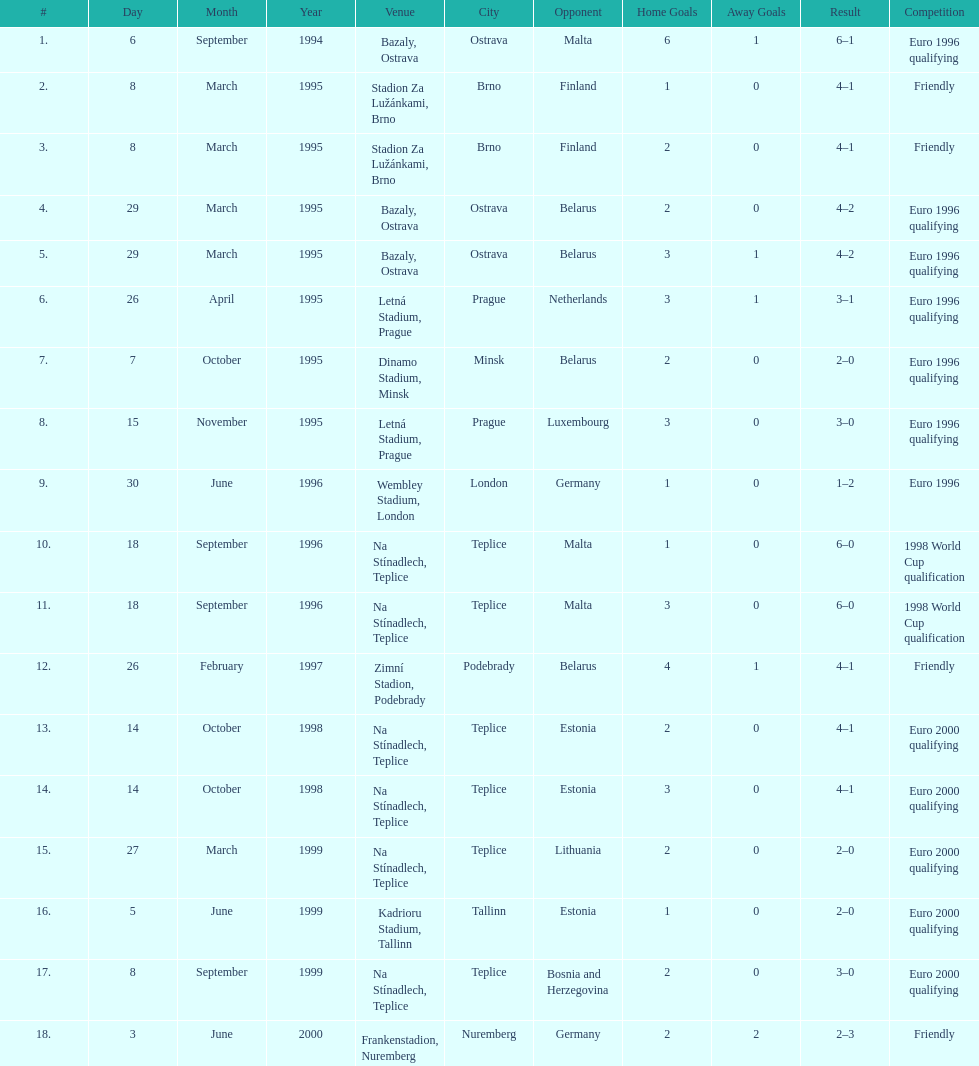Could you help me parse every detail presented in this table? {'header': ['#', 'Day', 'Month', 'Year', 'Venue', 'City', 'Opponent', 'Home Goals', 'Away Goals', 'Result', 'Competition'], 'rows': [['1.', '6', 'September', '1994', 'Bazaly, Ostrava', 'Ostrava', 'Malta', '6', '1', '6–1', 'Euro 1996 qualifying'], ['2.', '8', 'March', '1995', 'Stadion Za Lužánkami, Brno', 'Brno', 'Finland', '1', '0', '4–1', 'Friendly'], ['3.', '8', 'March', '1995', 'Stadion Za Lužánkami, Brno', 'Brno', 'Finland', '2', '0', '4–1', 'Friendly'], ['4.', '29', 'March', '1995', 'Bazaly, Ostrava', 'Ostrava', 'Belarus', '2', '0', '4–2', 'Euro 1996 qualifying'], ['5.', '29', 'March', '1995', 'Bazaly, Ostrava', 'Ostrava', 'Belarus', '3', '1', '4–2', 'Euro 1996 qualifying'], ['6.', '26', 'April', '1995', 'Letná Stadium, Prague', 'Prague', 'Netherlands', '3', '1', '3–1', 'Euro 1996 qualifying'], ['7.', '7', 'October', '1995', 'Dinamo Stadium, Minsk', 'Minsk', 'Belarus', '2', '0', '2–0', 'Euro 1996 qualifying'], ['8.', '15', 'November', '1995', 'Letná Stadium, Prague', 'Prague', 'Luxembourg', '3', '0', '3–0', 'Euro 1996 qualifying'], ['9.', '30', 'June', '1996', 'Wembley Stadium, London', 'London', 'Germany', '1', '0', '1–2', 'Euro 1996'], ['10.', '18', 'September', '1996', 'Na Stínadlech, Teplice', 'Teplice', 'Malta', '1', '0', '6–0', '1998 World Cup qualification'], ['11.', '18', 'September', '1996', 'Na Stínadlech, Teplice', 'Teplice', 'Malta', '3', '0', '6–0', '1998 World Cup qualification'], ['12.', '26', 'February', '1997', 'Zimní Stadion, Podebrady', 'Podebrady', 'Belarus', '4', '1', '4–1', 'Friendly'], ['13.', '14', 'October', '1998', 'Na Stínadlech, Teplice', 'Teplice', 'Estonia', '2', '0', '4–1', 'Euro 2000 qualifying'], ['14.', '14', 'October', '1998', 'Na Stínadlech, Teplice', 'Teplice', 'Estonia', '3', '0', '4–1', 'Euro 2000 qualifying'], ['15.', '27', 'March', '1999', 'Na Stínadlech, Teplice', 'Teplice', 'Lithuania', '2', '0', '2–0', 'Euro 2000 qualifying'], ['16.', '5', 'June', '1999', 'Kadrioru Stadium, Tallinn', 'Tallinn', 'Estonia', '1', '0', '2–0', 'Euro 2000 qualifying'], ['17.', '8', 'September', '1999', 'Na Stínadlech, Teplice', 'Teplice', 'Bosnia and Herzegovina', '2', '0', '3–0', 'Euro 2000 qualifying'], ['18.', '3', 'June', '2000', 'Frankenstadion, Nuremberg', 'Nuremberg', 'Germany', '2', '2', '2–3', 'Friendly']]} What opponent is listed last on the table? Germany. 